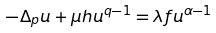Convert formula to latex. <formula><loc_0><loc_0><loc_500><loc_500>- \Delta _ { p } u + \mu h u ^ { q - 1 } = \lambda f u ^ { \alpha - 1 }</formula> 